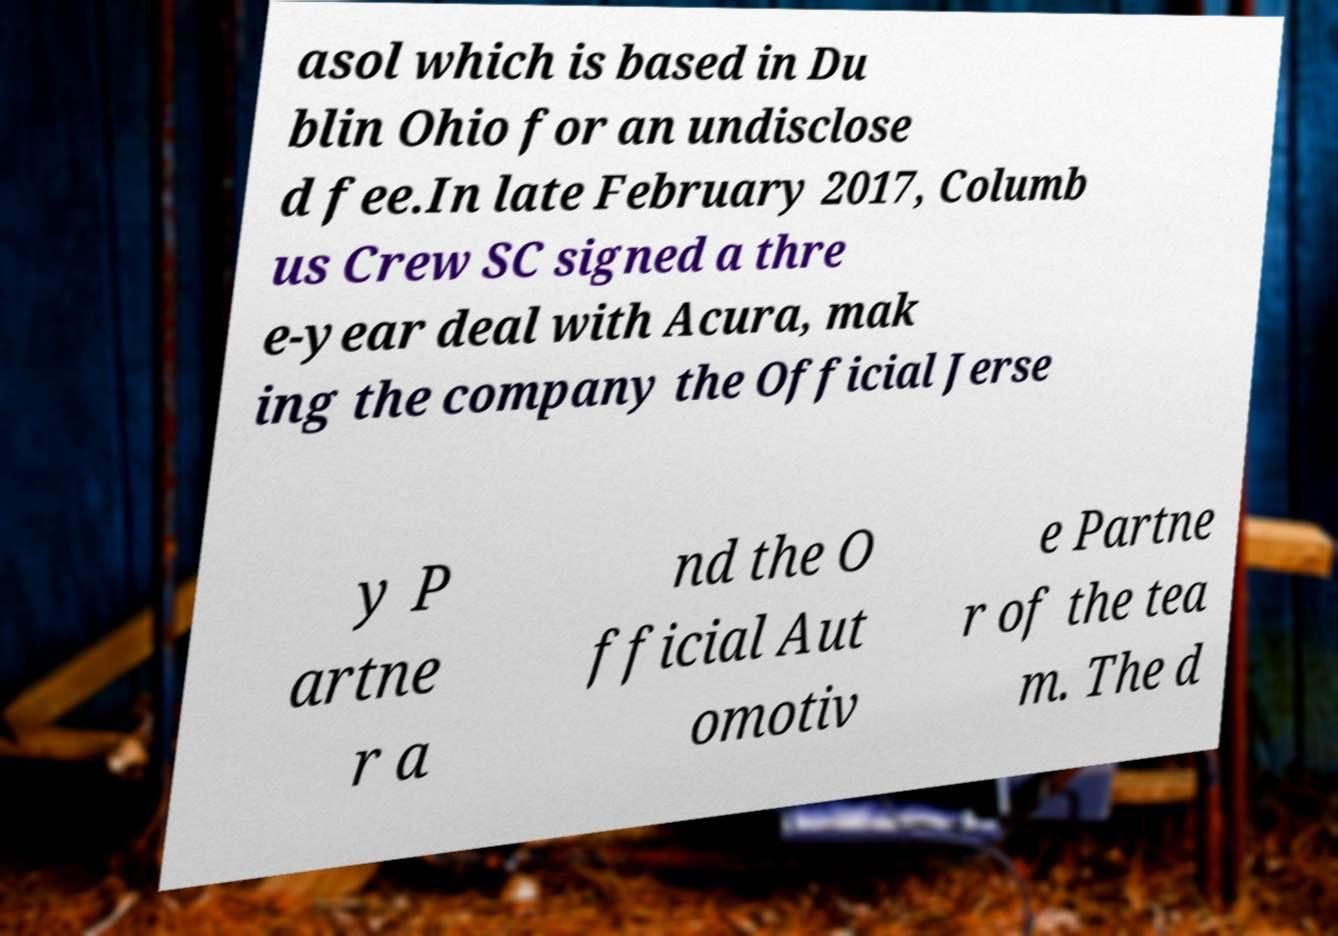Can you accurately transcribe the text from the provided image for me? asol which is based in Du blin Ohio for an undisclose d fee.In late February 2017, Columb us Crew SC signed a thre e-year deal with Acura, mak ing the company the Official Jerse y P artne r a nd the O fficial Aut omotiv e Partne r of the tea m. The d 